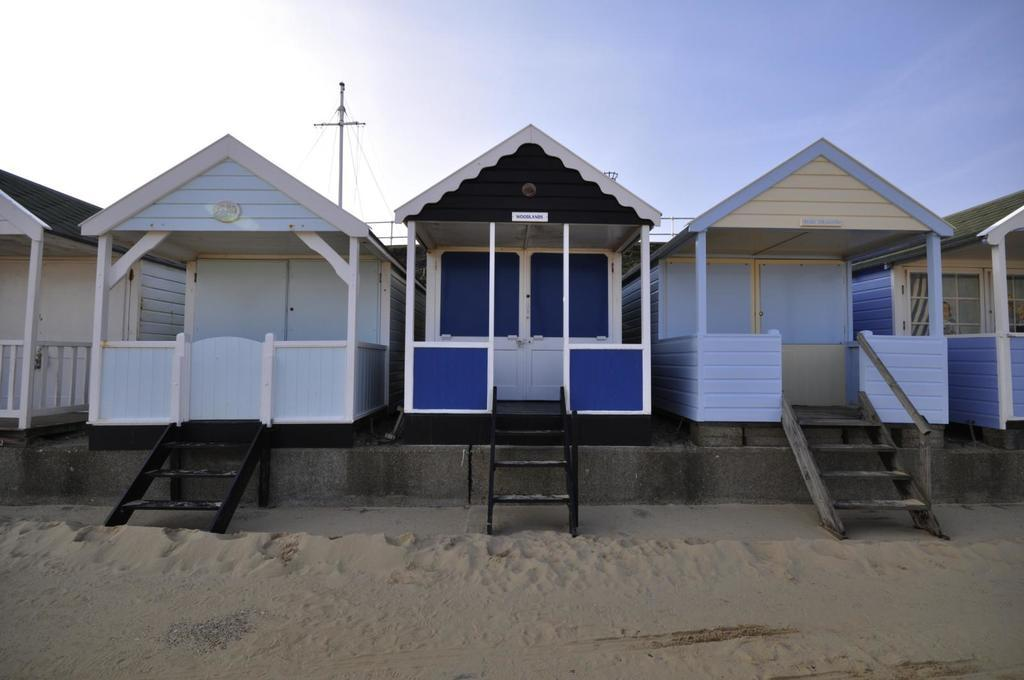What type of structures can be seen in the image? There are houses in the image. Are there any architectural features visible in the image? Yes, there are stairs in the image. What is visible beneath the structures and stairs? The ground is visible in the image. What is attached to the pole in the image? There is a pole with wires in the image. What part of the natural environment is visible in the image? The sky is visible in the image. What type of company is responsible for the disgusting smell in the image? There is no indication of any smell, let alone a disgusting one, in the image. The image only shows houses, stairs, the ground, a pole with wires, and the sky. 